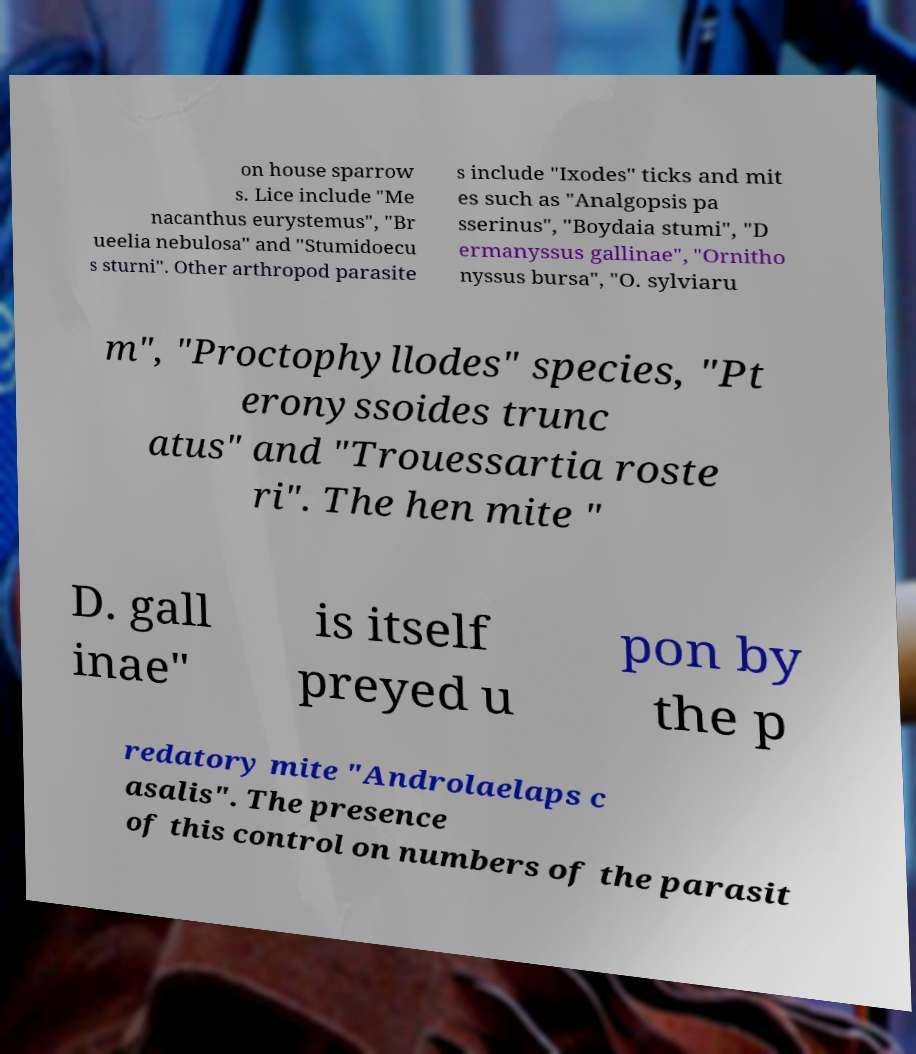Can you accurately transcribe the text from the provided image for me? on house sparrow s. Lice include "Me nacanthus eurystemus", "Br ueelia nebulosa" and "Stumidoecu s sturni". Other arthropod parasite s include "Ixodes" ticks and mit es such as "Analgopsis pa sserinus", "Boydaia stumi", "D ermanyssus gallinae", "Ornitho nyssus bursa", "O. sylviaru m", "Proctophyllodes" species, "Pt eronyssoides trunc atus" and "Trouessartia roste ri". The hen mite " D. gall inae" is itself preyed u pon by the p redatory mite "Androlaelaps c asalis". The presence of this control on numbers of the parasit 